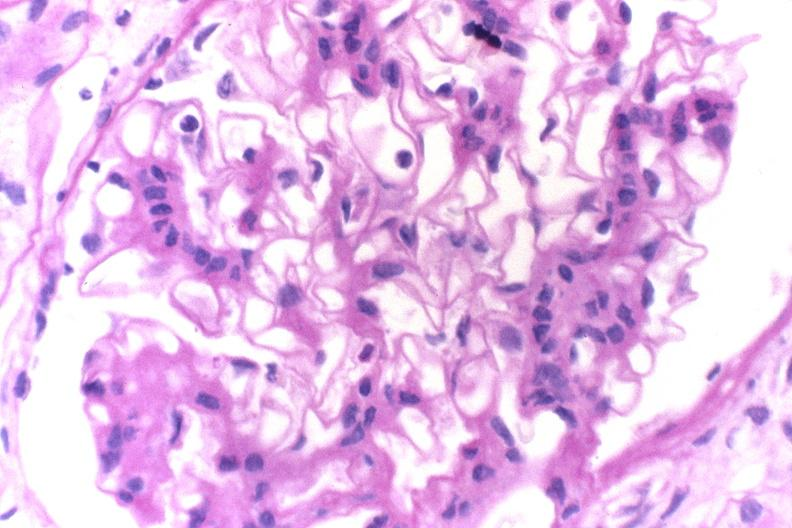s urinary present?
Answer the question using a single word or phrase. Yes 